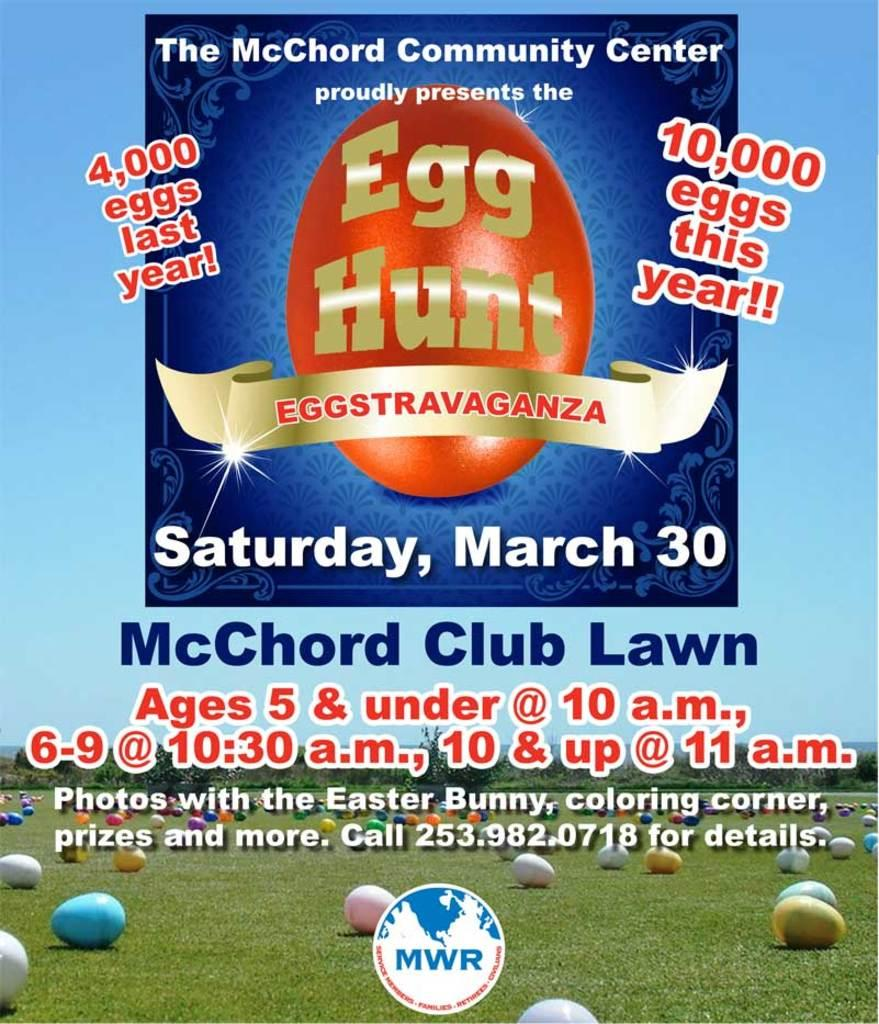<image>
Summarize the visual content of the image. A flyer is advertising an annual egg hunt provided by The McChord Community Center with the dates and times. 